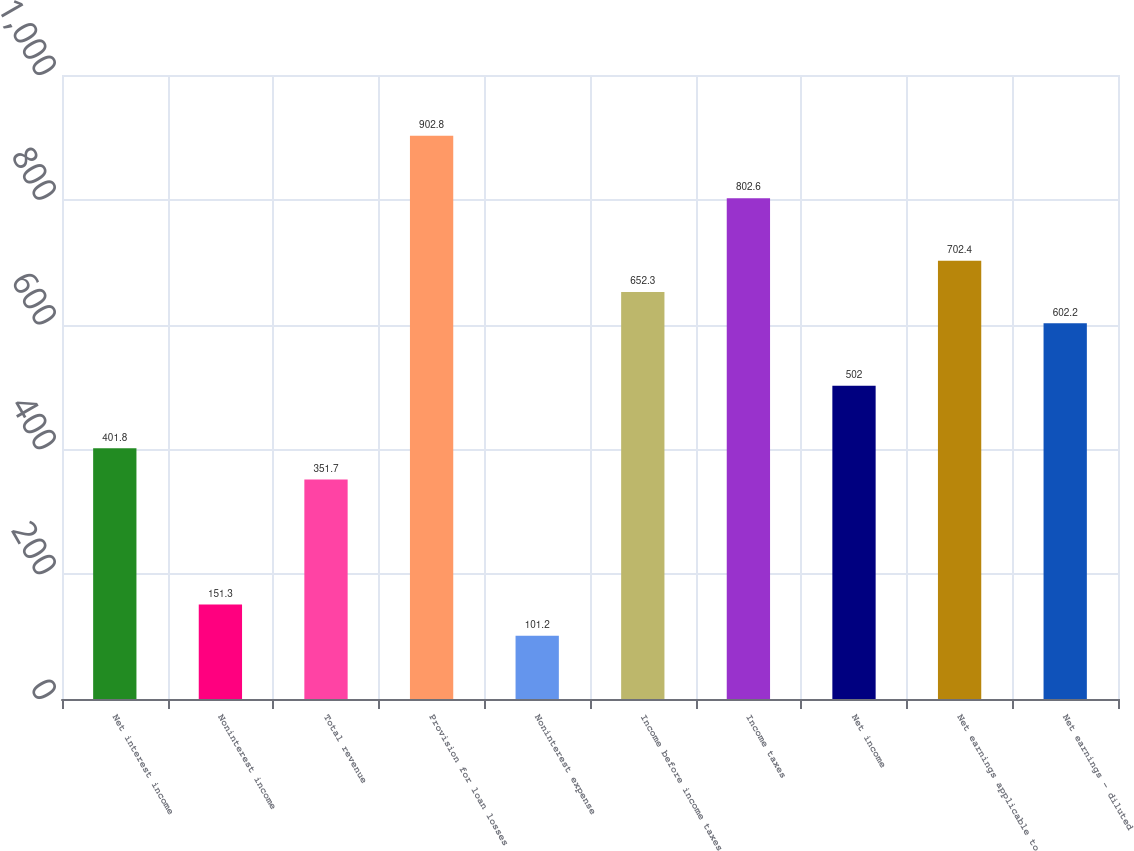Convert chart. <chart><loc_0><loc_0><loc_500><loc_500><bar_chart><fcel>Net interest income<fcel>Noninterest income<fcel>Total revenue<fcel>Provision for loan losses<fcel>Noninterest expense<fcel>Income before income taxes<fcel>Income taxes<fcel>Net income<fcel>Net earnings applicable to<fcel>Net earnings - diluted<nl><fcel>401.8<fcel>151.3<fcel>351.7<fcel>902.8<fcel>101.2<fcel>652.3<fcel>802.6<fcel>502<fcel>702.4<fcel>602.2<nl></chart> 